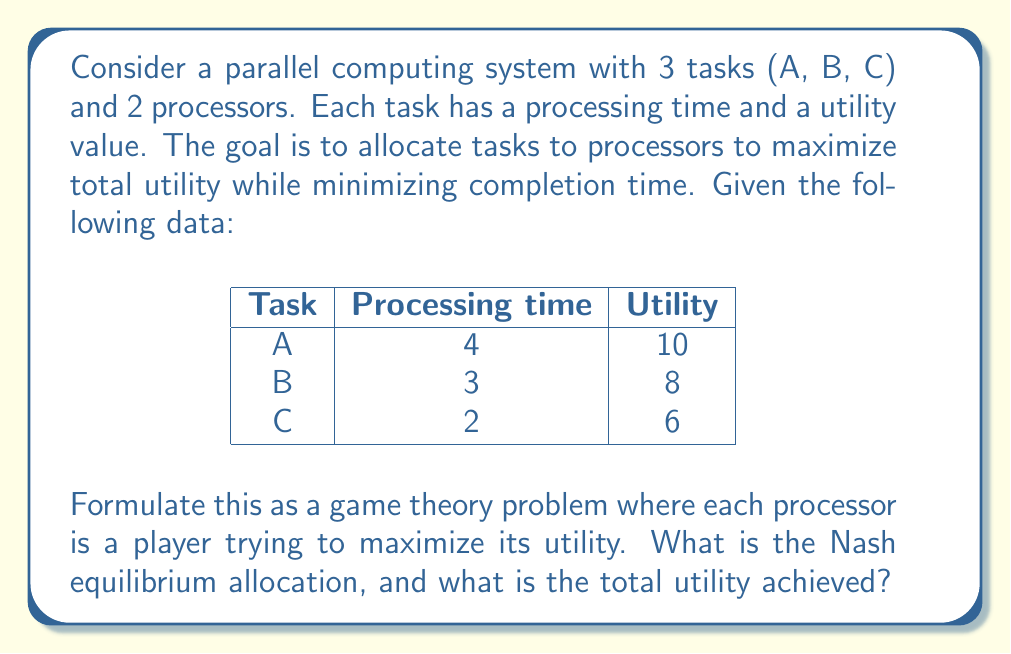Can you answer this question? To solve this problem, we'll use game theory concepts and analyze it as a strategic form game:

1. Players: Processor 1 and Processor 2

2. Strategies: Each processor can choose to execute any combination of tasks. The possible strategies are:
   - A
   - B
   - C
   - AB
   - AC
   - BC

3. Payoffs: The utility for each processor is the sum of the utilities of the tasks it executes, minus a penalty for its completion time. We'll use a penalty of -1 utility per unit of time.

Let's create a payoff matrix:

$$
\begin{array}{c|c|c|c|c|c|c}
P1 \backslash P2 & A & B & C & AB & AC & BC \\
\hline
A & 6,6 & 6,5 & 6,4 & 6,-1 & 6,-2 & 6,7 \\
B & 5,6 & 5,5 & 5,4 & 5,-1 & 5,8 & 5,-1 \\
C & 4,6 & 4,5 & 4,4 & 4,11 & 4,-2 & 4,-1 \\
AB & -1,6 & -1,5 & -1,4 & - & - & - \\
AC & -2,6 & 8,5 & -2,4 & - & - & - \\
BC & 7,6 & -1,5 & -1,4 & - & - & - \\
\end{array}
$$

To find the Nash equilibrium, we need to identify strategies where neither player can unilaterally improve their payoff.

Analyzing the matrix, we can see that the Nash equilibrium occurs when Processor 1 chooses AC and Processor 2 chooses B. In this allocation:

- Processor 1 executes tasks A and C, with a total processing time of 6 and a utility of 16, resulting in a payoff of 10 (16 - 6).
- Processor 2 executes task B, with a processing time of 3 and a utility of 8, resulting in a payoff of 5 (8 - 3).

Neither processor can improve their payoff by changing their strategy unilaterally.
Answer: The Nash equilibrium allocation is:
Processor 1: Tasks A and C
Processor 2: Task B

The total utility achieved is 24 (10 + 6 + 8). 